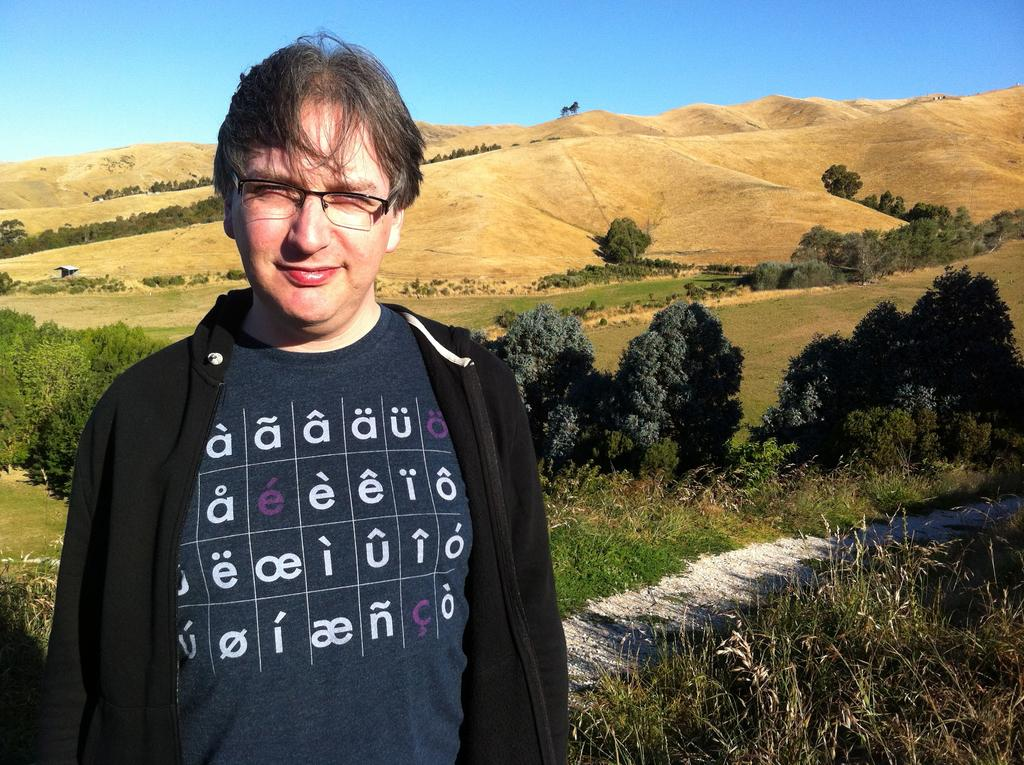Who is present in the image? There is a man in the image. What type of vegetation can be seen in the image? There are trees in the image. What is the ground covered with in the image? The ground is covered with grass in the image. What is the man wearing in the image? The man is wearing spectacles in the image. What color is the sky in the image? The sky is blue in the image. What type of sail can be seen on the man's boat in the image? There is no boat or sail present in the image; it features a man, trees, grass, and a blue sky. What type of operation is the man performing on the bear in the image? There is no bear or operation present in the image; it features a man, trees, grass, and a blue sky. 